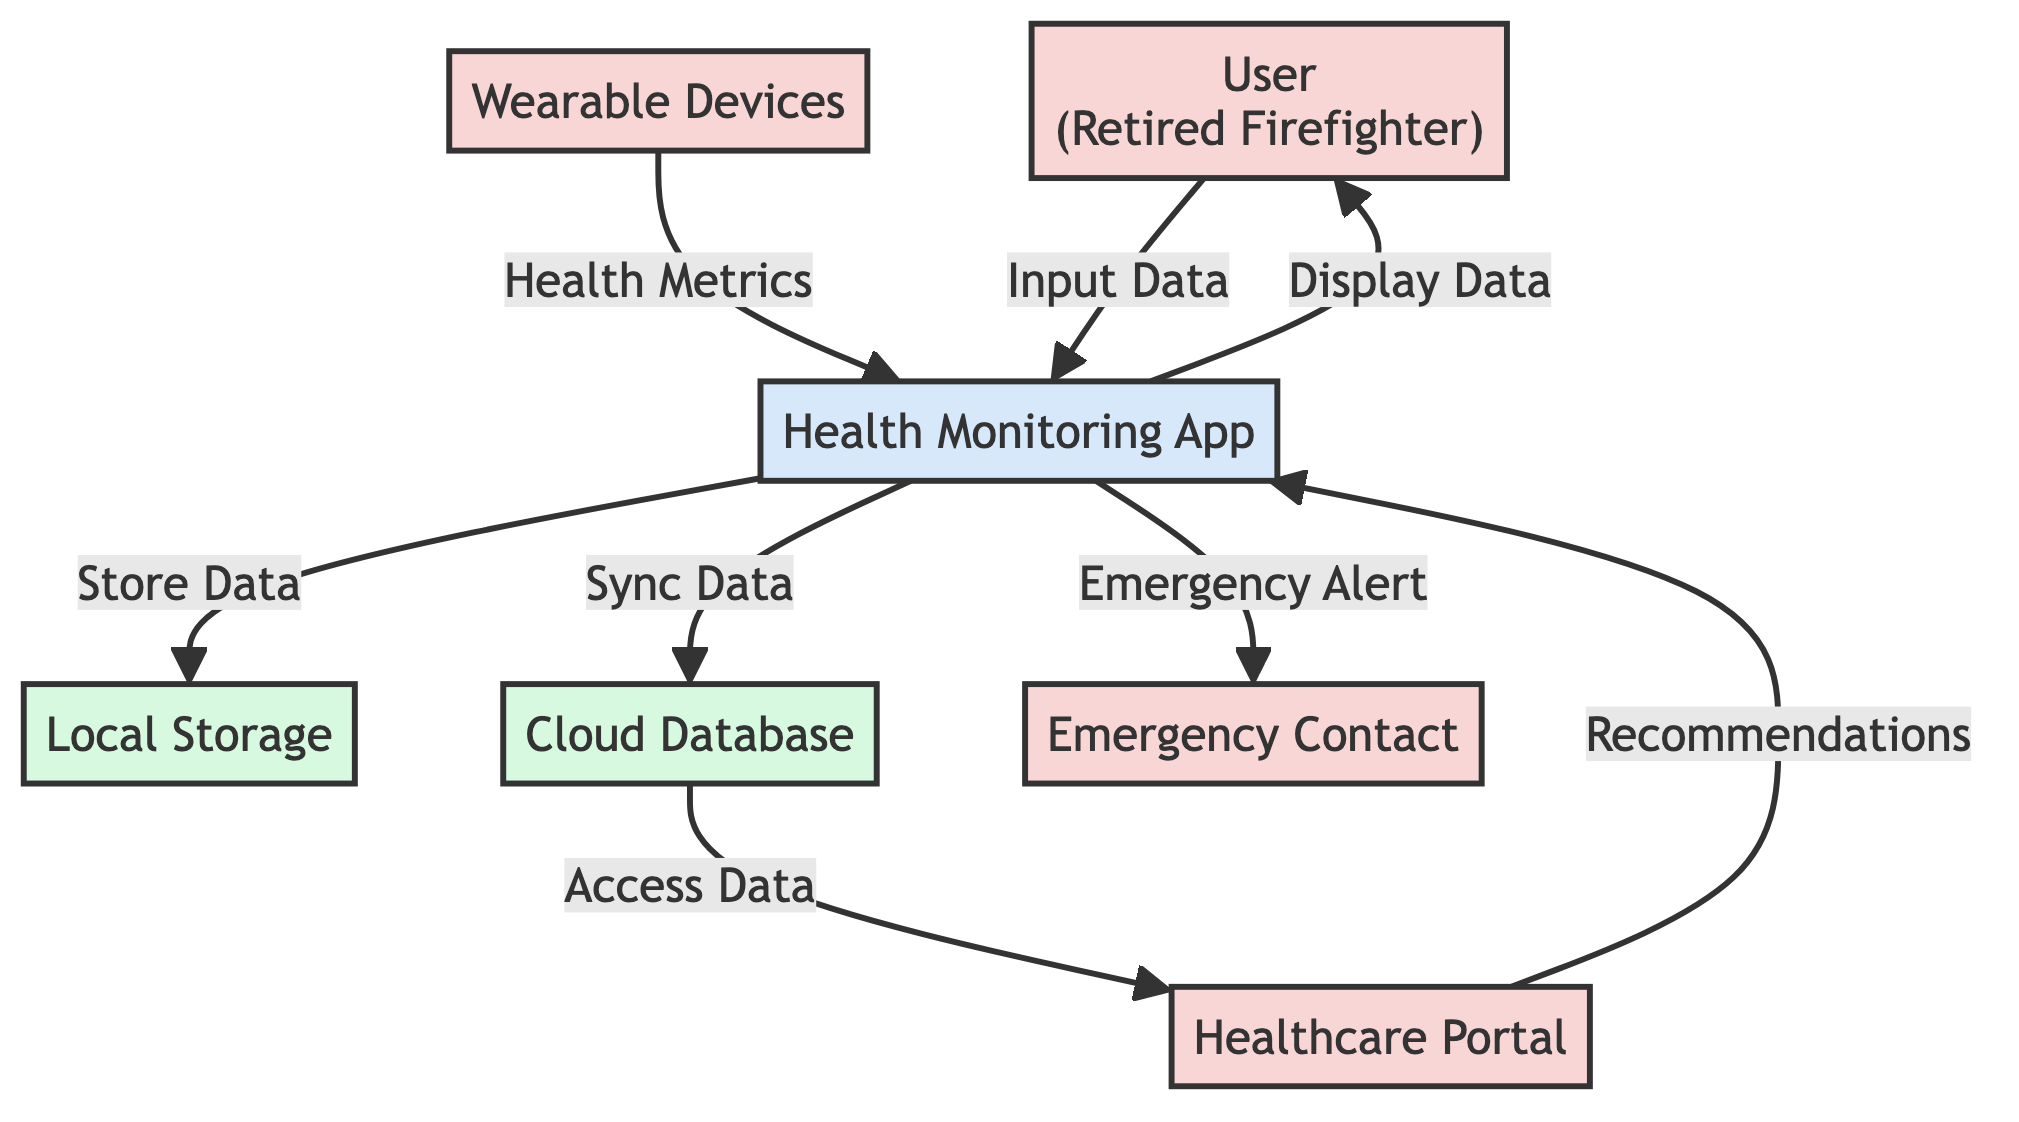What is the main actor in the diagram? The main actor is represented by the entity labeled "User (Retired Firefighter)," which indicates the central figure interacting with the health monitoring system.
Answer: User (Retired Firefighter) How many data stores are depicted in the diagram? The diagram shows two data stores: "Local Storage" and "Cloud Database." Therefore, the count is determined by identifying each data store symbol in the visual representation.
Answer: 2 What type of relationship exists between "Wearable Devices" and "Health Monitoring App"? The relationship is defined by the data flow labeled "Health Metrics," which indicates that the wearable devices collect data and send it to the Health Monitoring App, establishing a one-way flow of information.
Answer: Health Metrics What type of data flow occurs from "Health Monitoring App" to "Emergency Contact"? The data flow is marked as "Emergency Alert," showing that the Health Monitoring App sends notifications alerting the Emergency Contact in case of a health emergency, representing a specific function of alerting.
Answer: Emergency Alert Which external entity accesses data from the "Cloud Database"? The "Healthcare Portal" is the external entity that accesses data from the Cloud Database, as indicated by the data flow labeled "Access Data," establishing a connection for retrieving health information.
Answer: Healthcare Portal What does the "Health Monitoring App" do with the data it collects? The "Health Monitoring App" processes the data by syncing it to the "Cloud Database" and displaying it to the user, fulfilling its role in health management and communication.
Answer: Sync Data, Display Data Which two processes are involved in data storage in the diagram? The two processes involved are "Sync Data," which sends data to the Cloud Database, and "Store Data," which holds data in Local Storage on the user’s smartphone. These two processes highlight where data is stored.
Answer: Sync Data, Store Data How are recommendations delivered to the user? Recommendations are delivered through the data flow labeled "Recommendations," which indicates that the Healthcare Portal sends health suggestions and advice to the User via the Health Monitoring App, creating a feedback loop.
Answer: Recommendations What triggers the "Emergency Alert"? The "Emergency Alert" is triggered by critical health events detected by the Health Monitoring App, indicating a direct response to situations that may require an emergency notification to the designated contact.
Answer: Health Monitoring App 